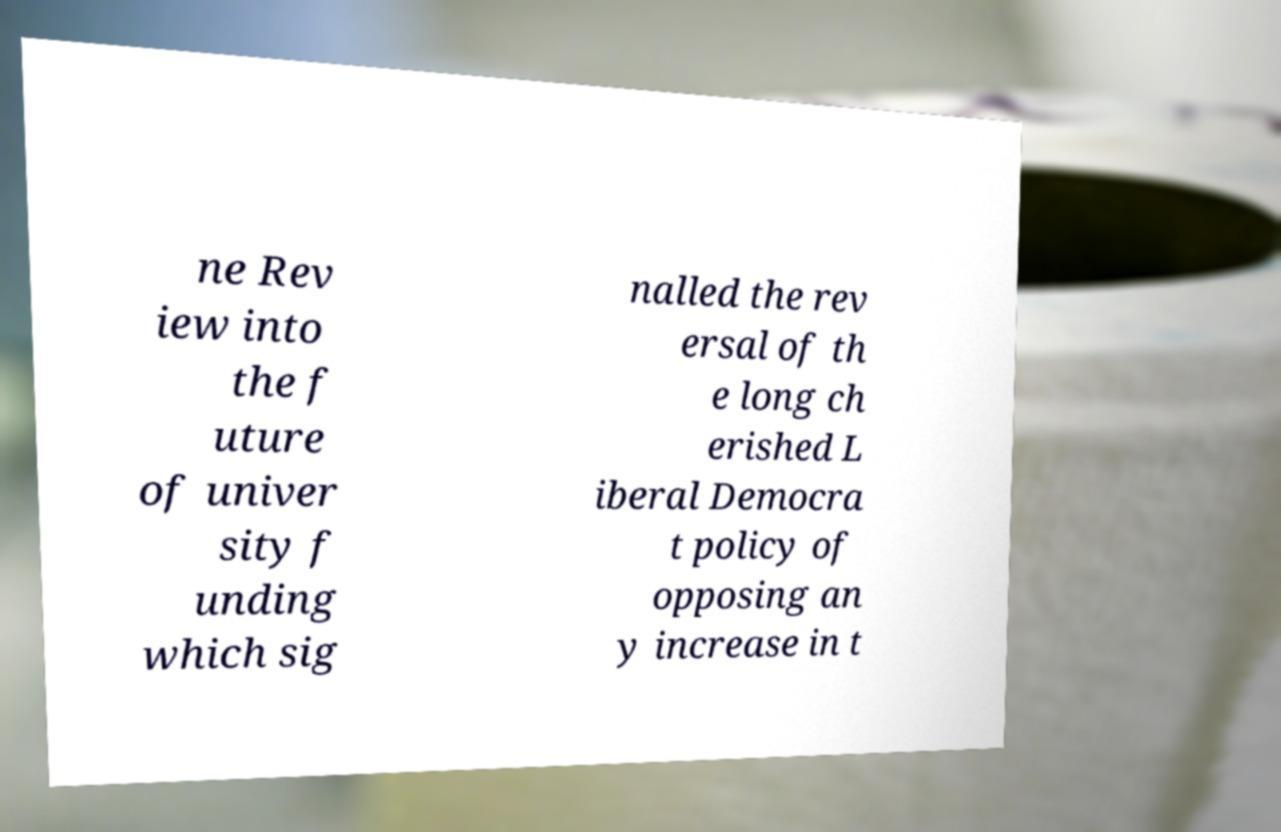Please identify and transcribe the text found in this image. ne Rev iew into the f uture of univer sity f unding which sig nalled the rev ersal of th e long ch erished L iberal Democra t policy of opposing an y increase in t 